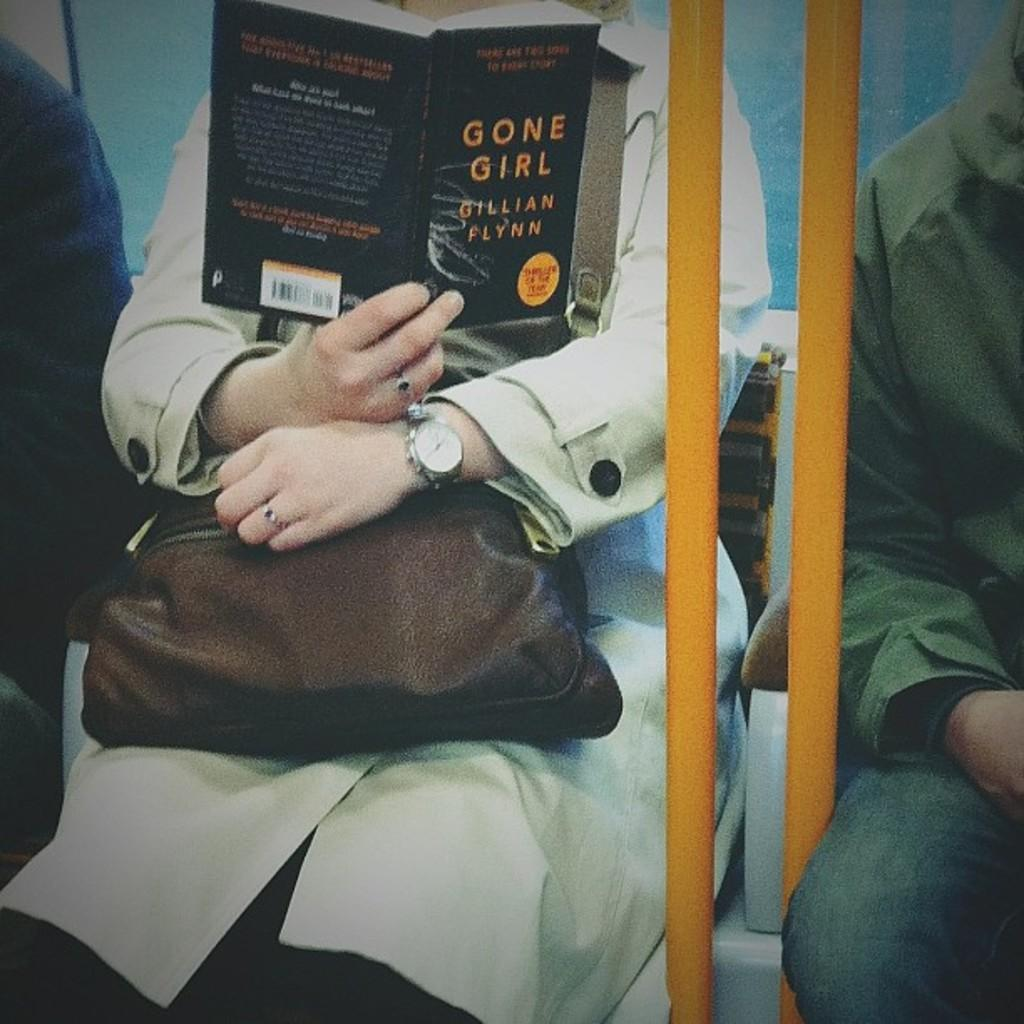<image>
Provide a brief description of the given image. A woman sits on a bus reading the novel Gone Girl. 